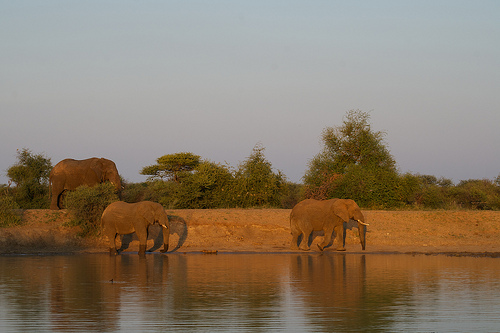What time of day does this image appear to have been taken? The image appears to have been captured during the golden hours, which are typically shortly after sunrise or just before sunset, as indicated by the warm lighting and long shadows cast by the elephants. 